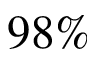<formula> <loc_0><loc_0><loc_500><loc_500>9 8 \%</formula> 